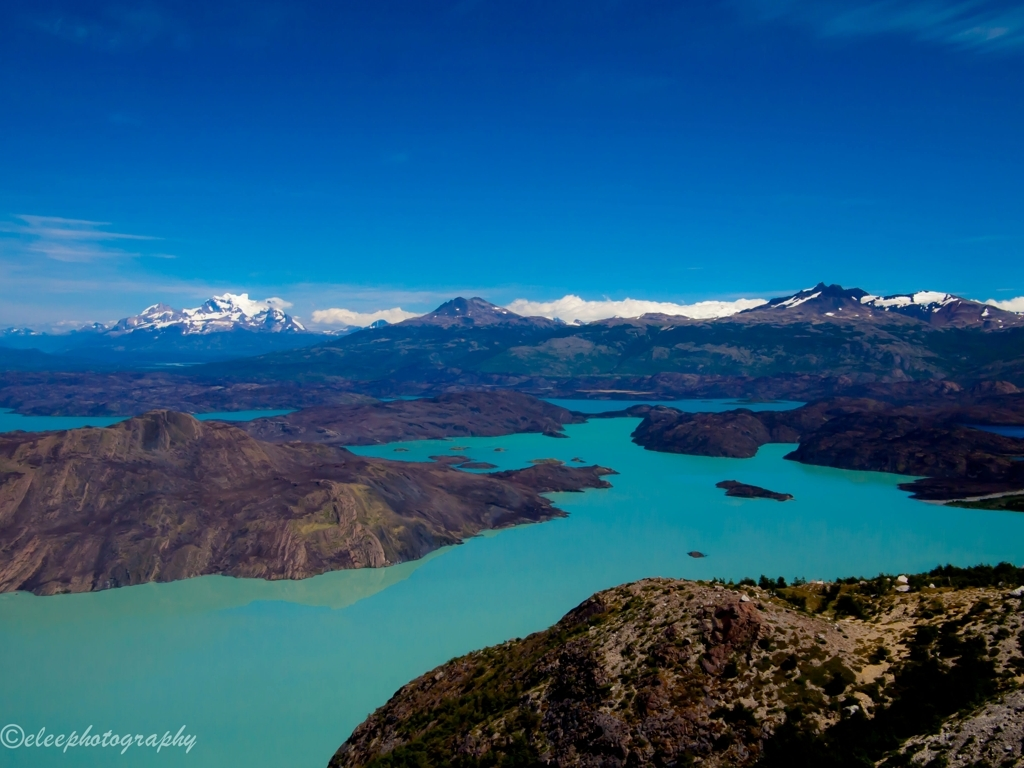What activities might visitors engage in at this location? Visitors to this breathtaking locale could engage in a variety of outdoor activities. Hiking would be a main attraction, given the expansive trails and scenic vantage points. Kayaking or boating on the lake's calm waters would offer a unique perspective of the landscape. Photography enthusiasts would find endless inspiration in the natural beauty and wildlife. For the more adventurous, rock climbing on the craggy terrain could be a highlight. 